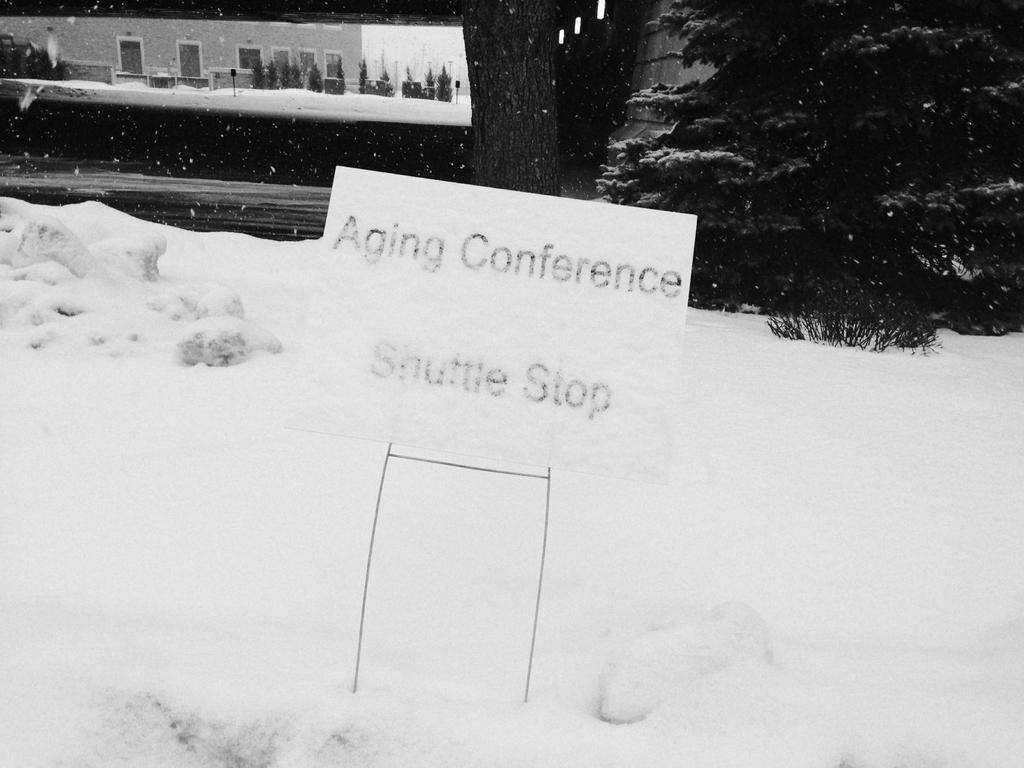What is the main feature of the landscape in the image? There is snow in the image. What object is placed on the snow? There is a board on the snow. What is written or depicted on the board? There is text on the board. What type of vegetation can be seen on the right side of the image? There are trees visible on the right side of the image. Can you identify any structures in the middle of the image? There might be a building visible in the middle of the image. What is visible at the top of the image? The sky is visible at the top of the image. What is the opinion of the snow in the image? The image does not express an opinion about the snow; it simply depicts the snow as a part of the landscape. 